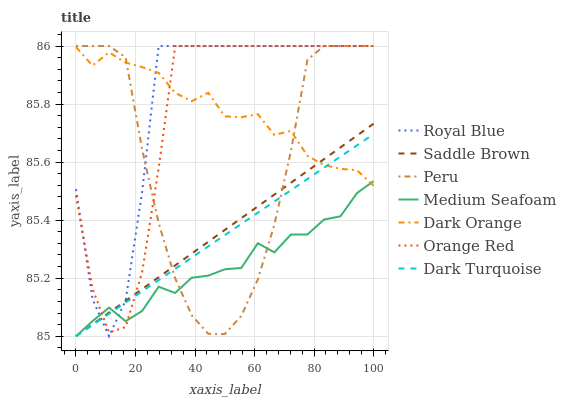Does Medium Seafoam have the minimum area under the curve?
Answer yes or no. Yes. Does Royal Blue have the maximum area under the curve?
Answer yes or no. Yes. Does Dark Turquoise have the minimum area under the curve?
Answer yes or no. No. Does Dark Turquoise have the maximum area under the curve?
Answer yes or no. No. Is Saddle Brown the smoothest?
Answer yes or no. Yes. Is Royal Blue the roughest?
Answer yes or no. Yes. Is Dark Turquoise the smoothest?
Answer yes or no. No. Is Dark Turquoise the roughest?
Answer yes or no. No. Does Dark Turquoise have the lowest value?
Answer yes or no. Yes. Does Royal Blue have the lowest value?
Answer yes or no. No. Does Orange Red have the highest value?
Answer yes or no. Yes. Does Dark Turquoise have the highest value?
Answer yes or no. No. Does Royal Blue intersect Dark Orange?
Answer yes or no. Yes. Is Royal Blue less than Dark Orange?
Answer yes or no. No. Is Royal Blue greater than Dark Orange?
Answer yes or no. No. 